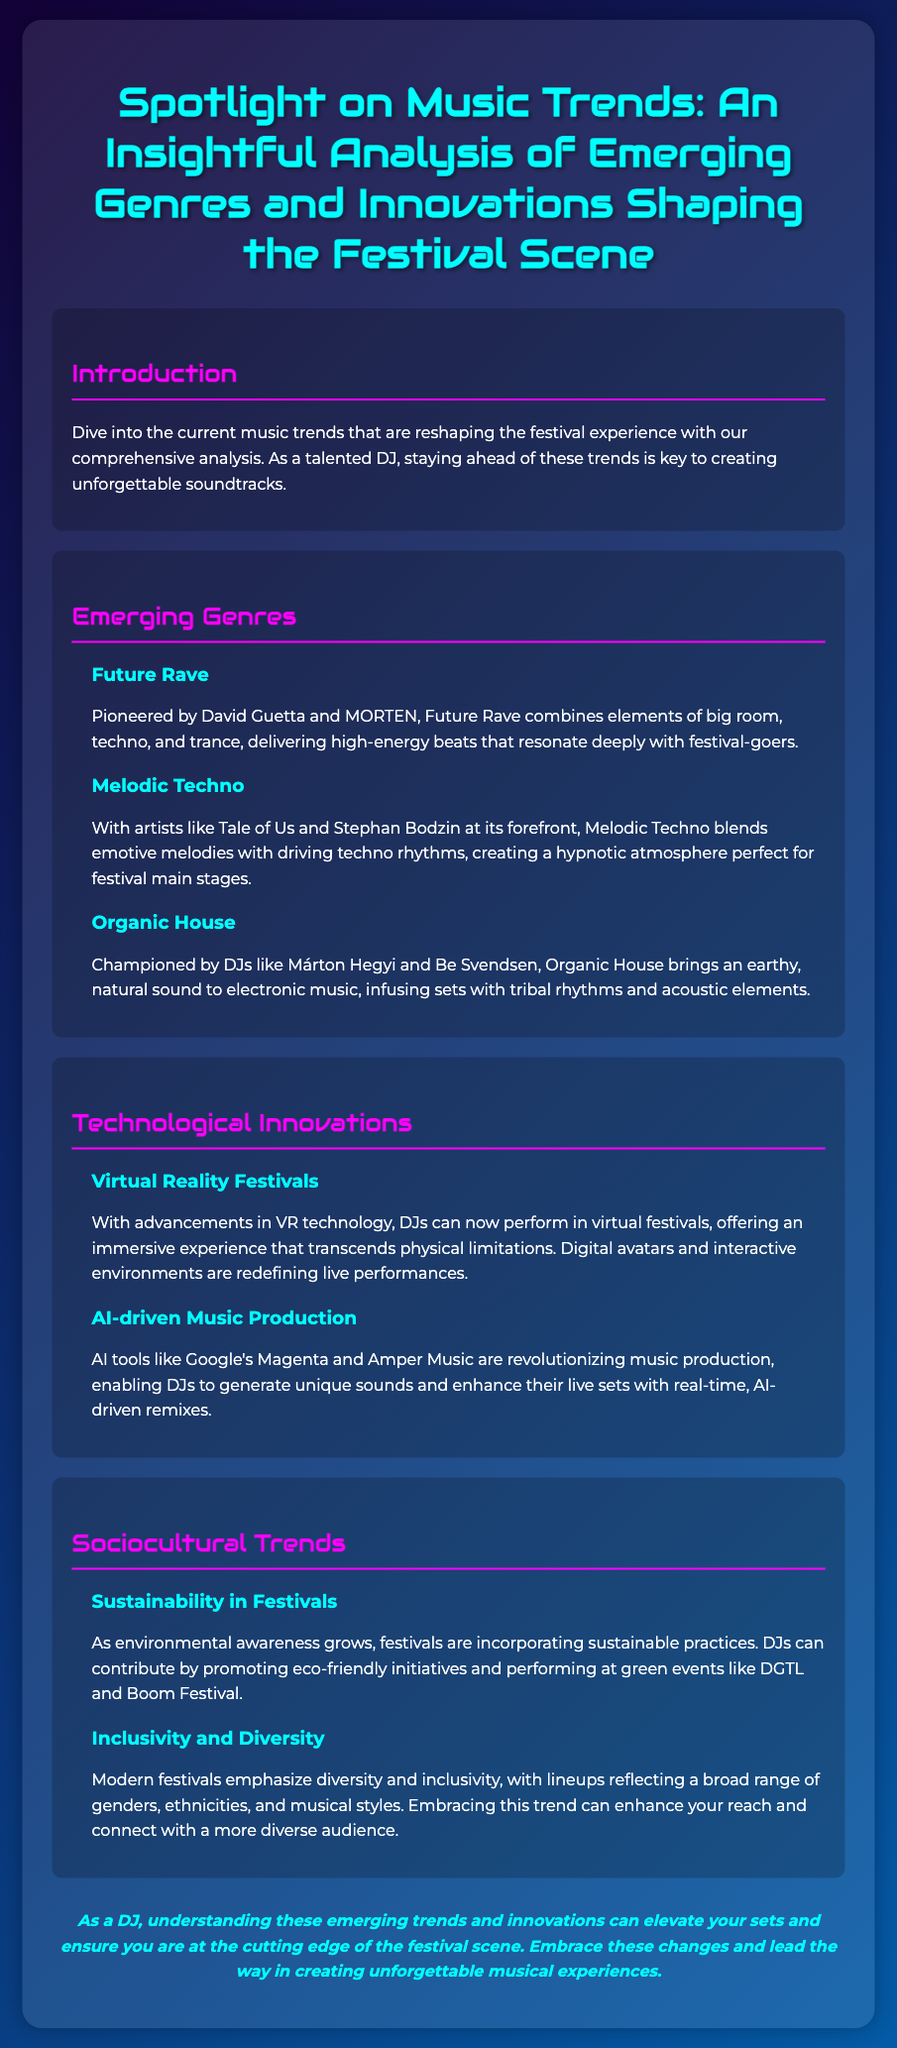what is the title of the document? The title of the document is prominently displayed at the top of the Playbill.
Answer: Spotlight on Music Trends: An Insightful Analysis of Emerging Genres and Innovations Shaping the Festival Scene who pioneered Future Rave? Future Rave is credited to two specific artists mentioned in the document.
Answer: David Guetta and MORTEN which genre blends emotive melodies with driving techno rhythms? The document describes several genres, specifying which one features emotive melodies blended with techno.
Answer: Melodic Techno what are DJs encouraged to promote according to the sociocultural trends section? The sociocultural trends section emphasizes a significant practice that festivals are incorporating.
Answer: eco-friendly initiatives what two technological advancements are discussed in relation to DJ performances? The document outlines two specific advancements that enhance DJ performances.
Answer: Virtual Reality Festivals and AI-driven Music Production which festival is specifically mentioned as being eco-friendly? The document provides the name of a festival known for its sustainable practices.
Answer: DGTL how does the document describe the atmosphere created by Organic House? The document characterizes the sound and feel that Organic House brings to sets.
Answer: earthy, natural sound what is the main purpose of the Playbill? The main aim of the Playbill is to provide insight into the evolving festival music landscape.
Answer: to provide insight into music trends which aspect of festival culture is highlighted by the emphasis on diversity and inclusivity? The document discusses a cultural aspect that is increasingly prioritized in modern festivals.
Answer: diversity and inclusivity 